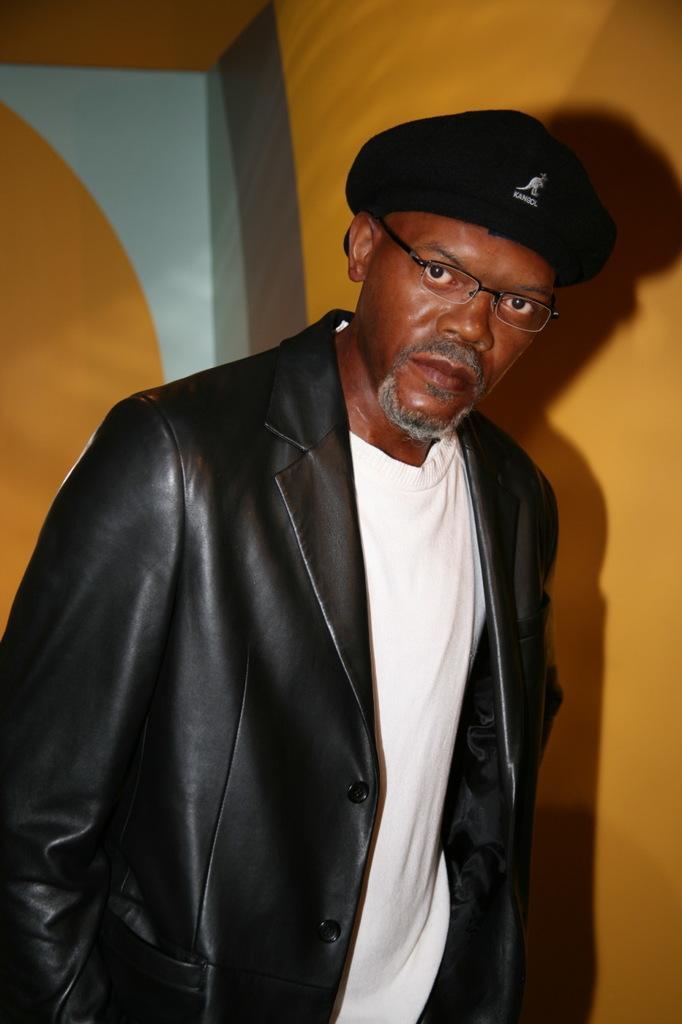How would you summarize this image in a sentence or two? In this image there is a person staring at the camera. 